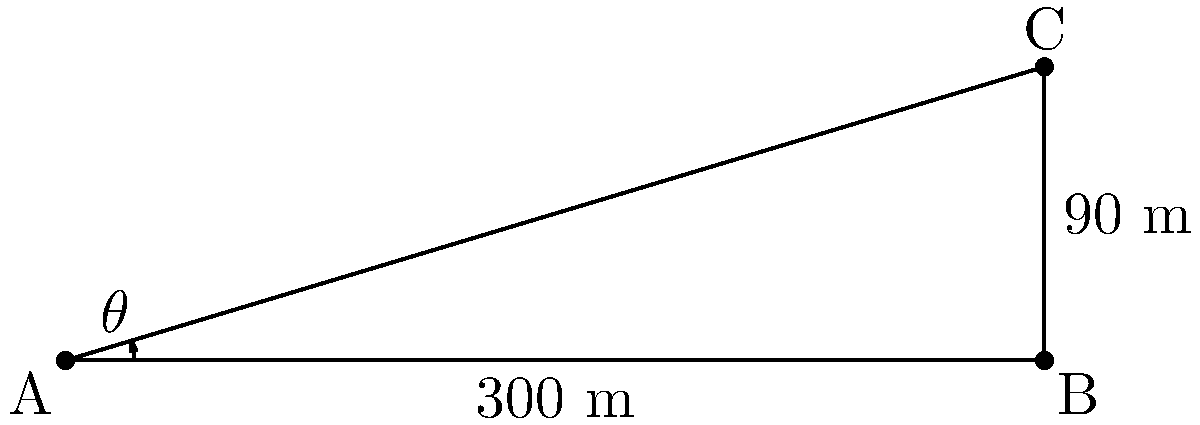As a tourism coordinator, you're planning a viewing area for the Eiffel Tower. From point A, the base of the tower is 300 meters away at point B, and the top of the tower is at point C, 90 meters above point B. What is the angle of elevation ($\theta$) from point A to the top of the tower (point C)? To find the angle of elevation, we need to use trigonometry. Let's approach this step-by-step:

1) We have a right triangle ABC, where:
   - AB is the distance to the base of the tower (300 m)
   - BC is the height of the tower (90 m)
   - AC is the line of sight from the viewing point to the top of the tower
   - The angle $\theta$ at A is what we need to find

2) We can use the tangent function to find this angle:

   $\tan(\theta) = \frac{\text{opposite}}{\text{adjacent}} = \frac{BC}{AB} = \frac{90}{300} = 0.3$

3) To get the angle, we need to use the inverse tangent (arctangent) function:

   $\theta = \arctan(0.3)$

4) Using a calculator or mathematical tables:

   $\theta \approx 16.70^\circ$

5) Round to two decimal places:

   $\theta \approx 16.70^\circ$

Thus, the angle of elevation from point A to the top of the Eiffel Tower is approximately 16.70°.
Answer: $16.70^\circ$ 